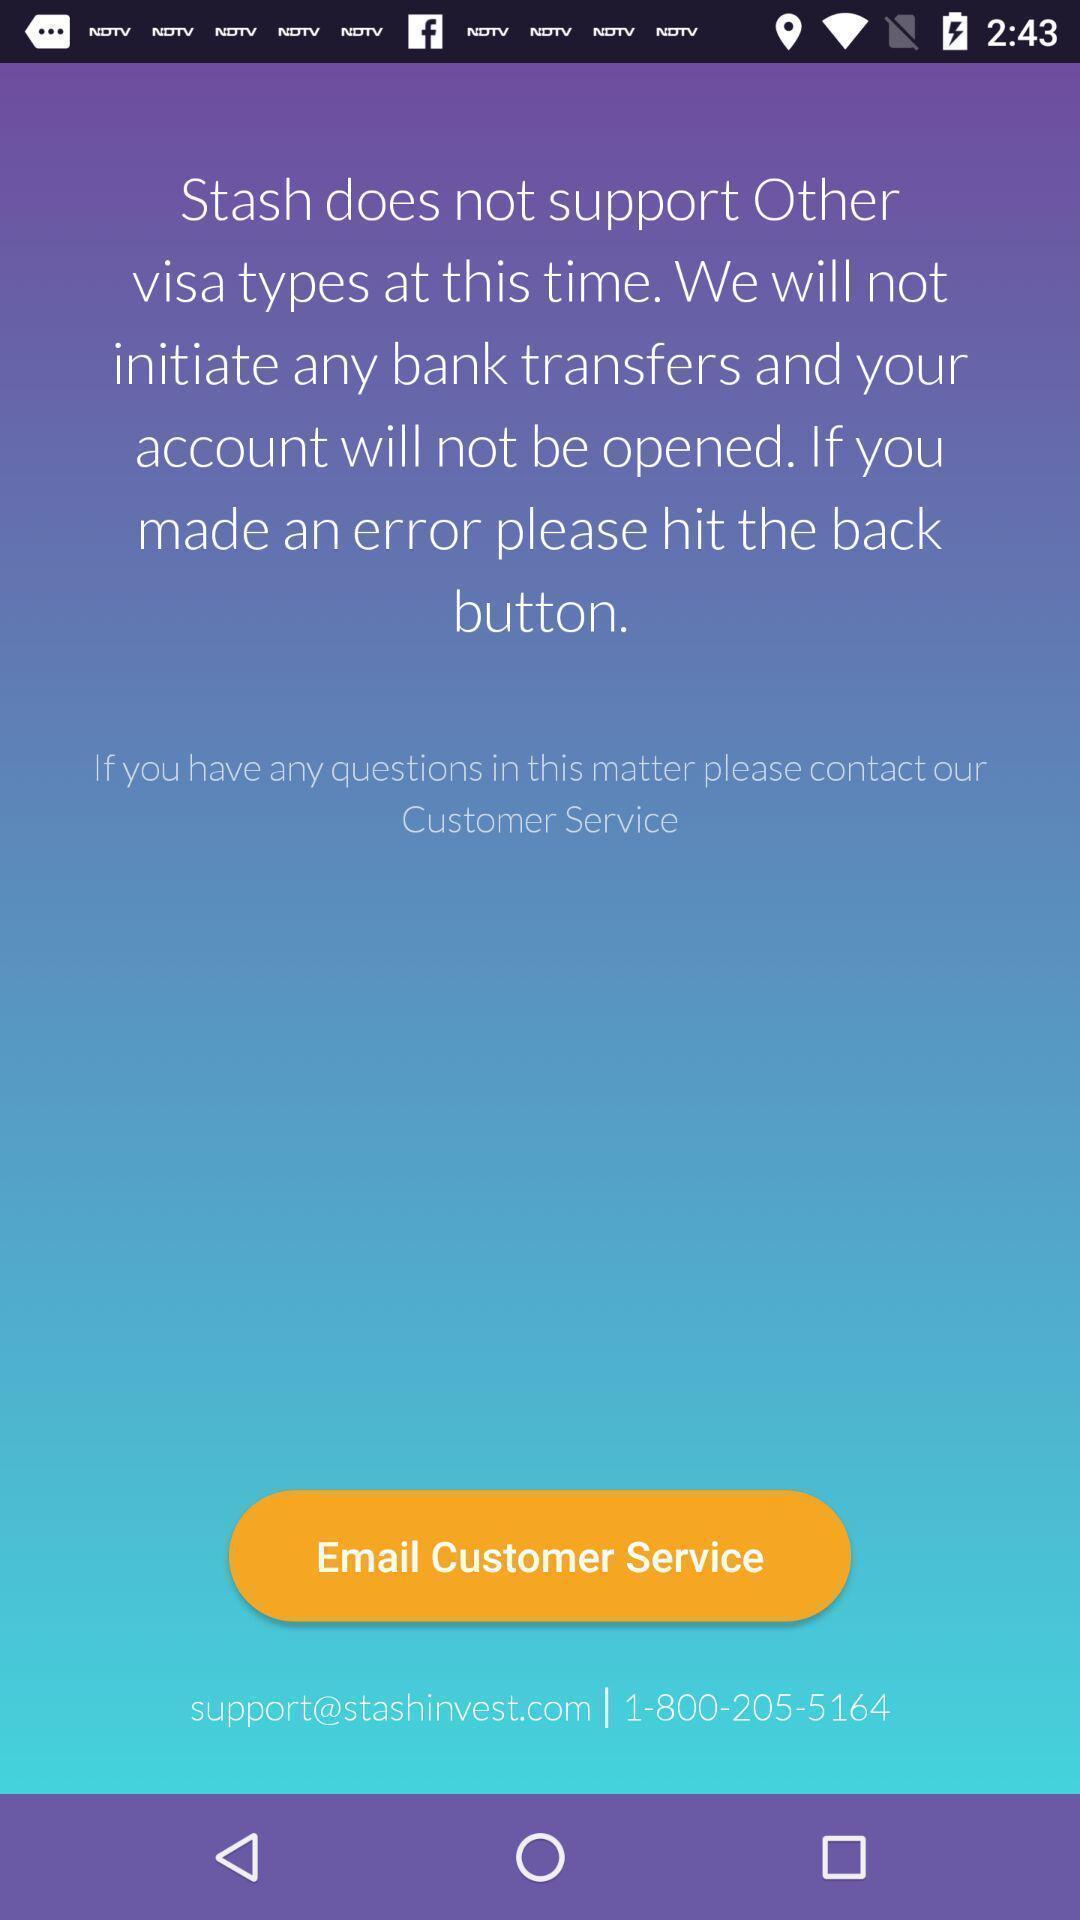Describe this image in words. Service page for customers in app. 